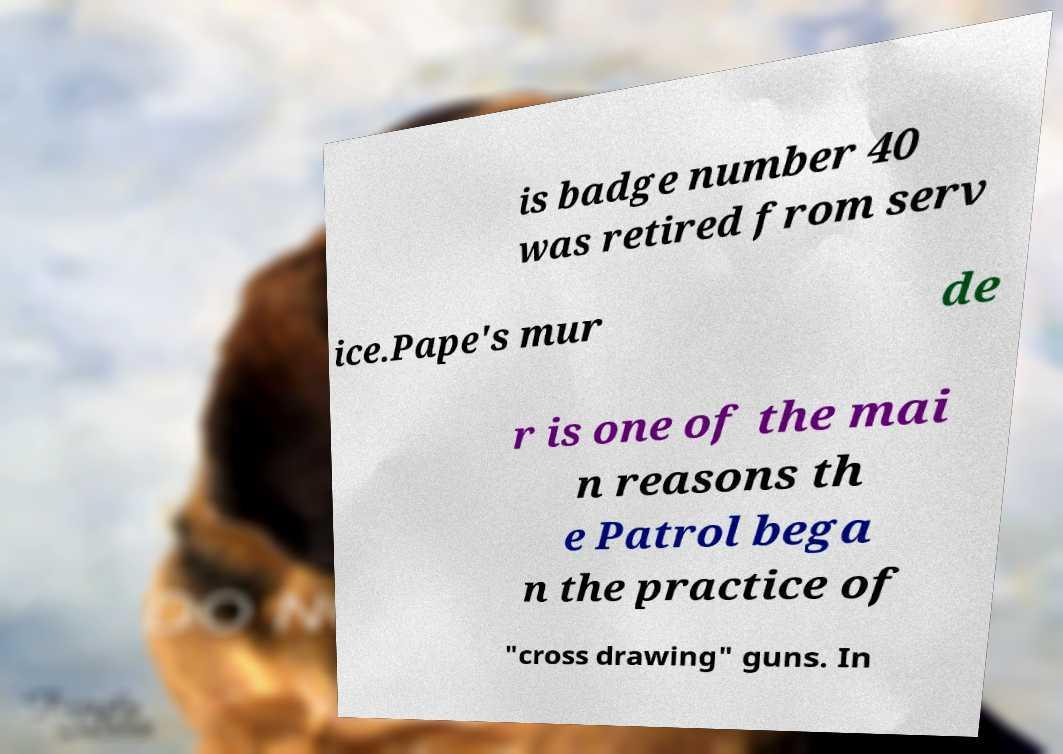Please identify and transcribe the text found in this image. is badge number 40 was retired from serv ice.Pape's mur de r is one of the mai n reasons th e Patrol bega n the practice of "cross drawing" guns. In 